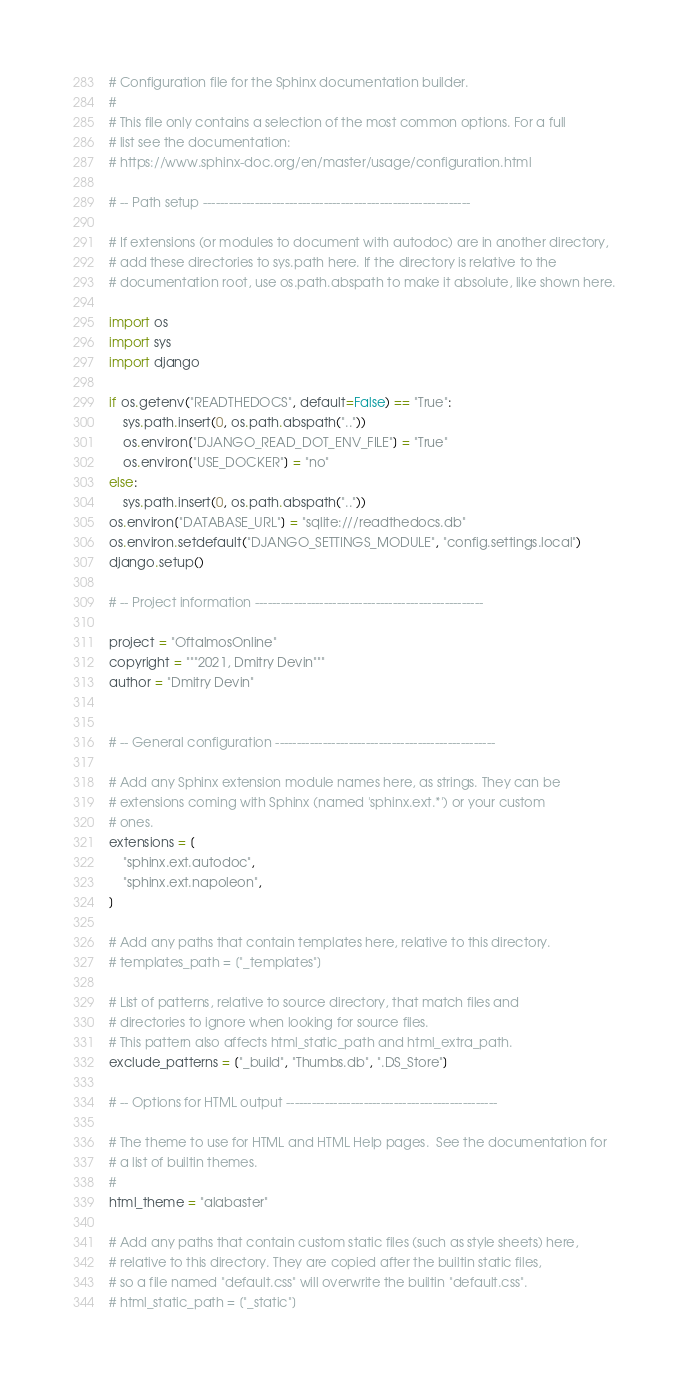Convert code to text. <code><loc_0><loc_0><loc_500><loc_500><_Python_># Configuration file for the Sphinx documentation builder.
#
# This file only contains a selection of the most common options. For a full
# list see the documentation:
# https://www.sphinx-doc.org/en/master/usage/configuration.html

# -- Path setup --------------------------------------------------------------

# If extensions (or modules to document with autodoc) are in another directory,
# add these directories to sys.path here. If the directory is relative to the
# documentation root, use os.path.abspath to make it absolute, like shown here.

import os
import sys
import django

if os.getenv("READTHEDOCS", default=False) == "True":
    sys.path.insert(0, os.path.abspath(".."))
    os.environ["DJANGO_READ_DOT_ENV_FILE"] = "True"
    os.environ["USE_DOCKER"] = "no"
else:
    sys.path.insert(0, os.path.abspath(".."))
os.environ["DATABASE_URL"] = "sqlite:///readthedocs.db"
os.environ.setdefault("DJANGO_SETTINGS_MODULE", "config.settings.local")
django.setup()

# -- Project information -----------------------------------------------------

project = "OftalmosOnline"
copyright = """2021, Dmitry Devin"""
author = "Dmitry Devin"


# -- General configuration ---------------------------------------------------

# Add any Sphinx extension module names here, as strings. They can be
# extensions coming with Sphinx (named 'sphinx.ext.*') or your custom
# ones.
extensions = [
    "sphinx.ext.autodoc",
    "sphinx.ext.napoleon",
]

# Add any paths that contain templates here, relative to this directory.
# templates_path = ["_templates"]

# List of patterns, relative to source directory, that match files and
# directories to ignore when looking for source files.
# This pattern also affects html_static_path and html_extra_path.
exclude_patterns = ["_build", "Thumbs.db", ".DS_Store"]

# -- Options for HTML output -------------------------------------------------

# The theme to use for HTML and HTML Help pages.  See the documentation for
# a list of builtin themes.
#
html_theme = "alabaster"

# Add any paths that contain custom static files (such as style sheets) here,
# relative to this directory. They are copied after the builtin static files,
# so a file named "default.css" will overwrite the builtin "default.css".
# html_static_path = ["_static"]
</code> 